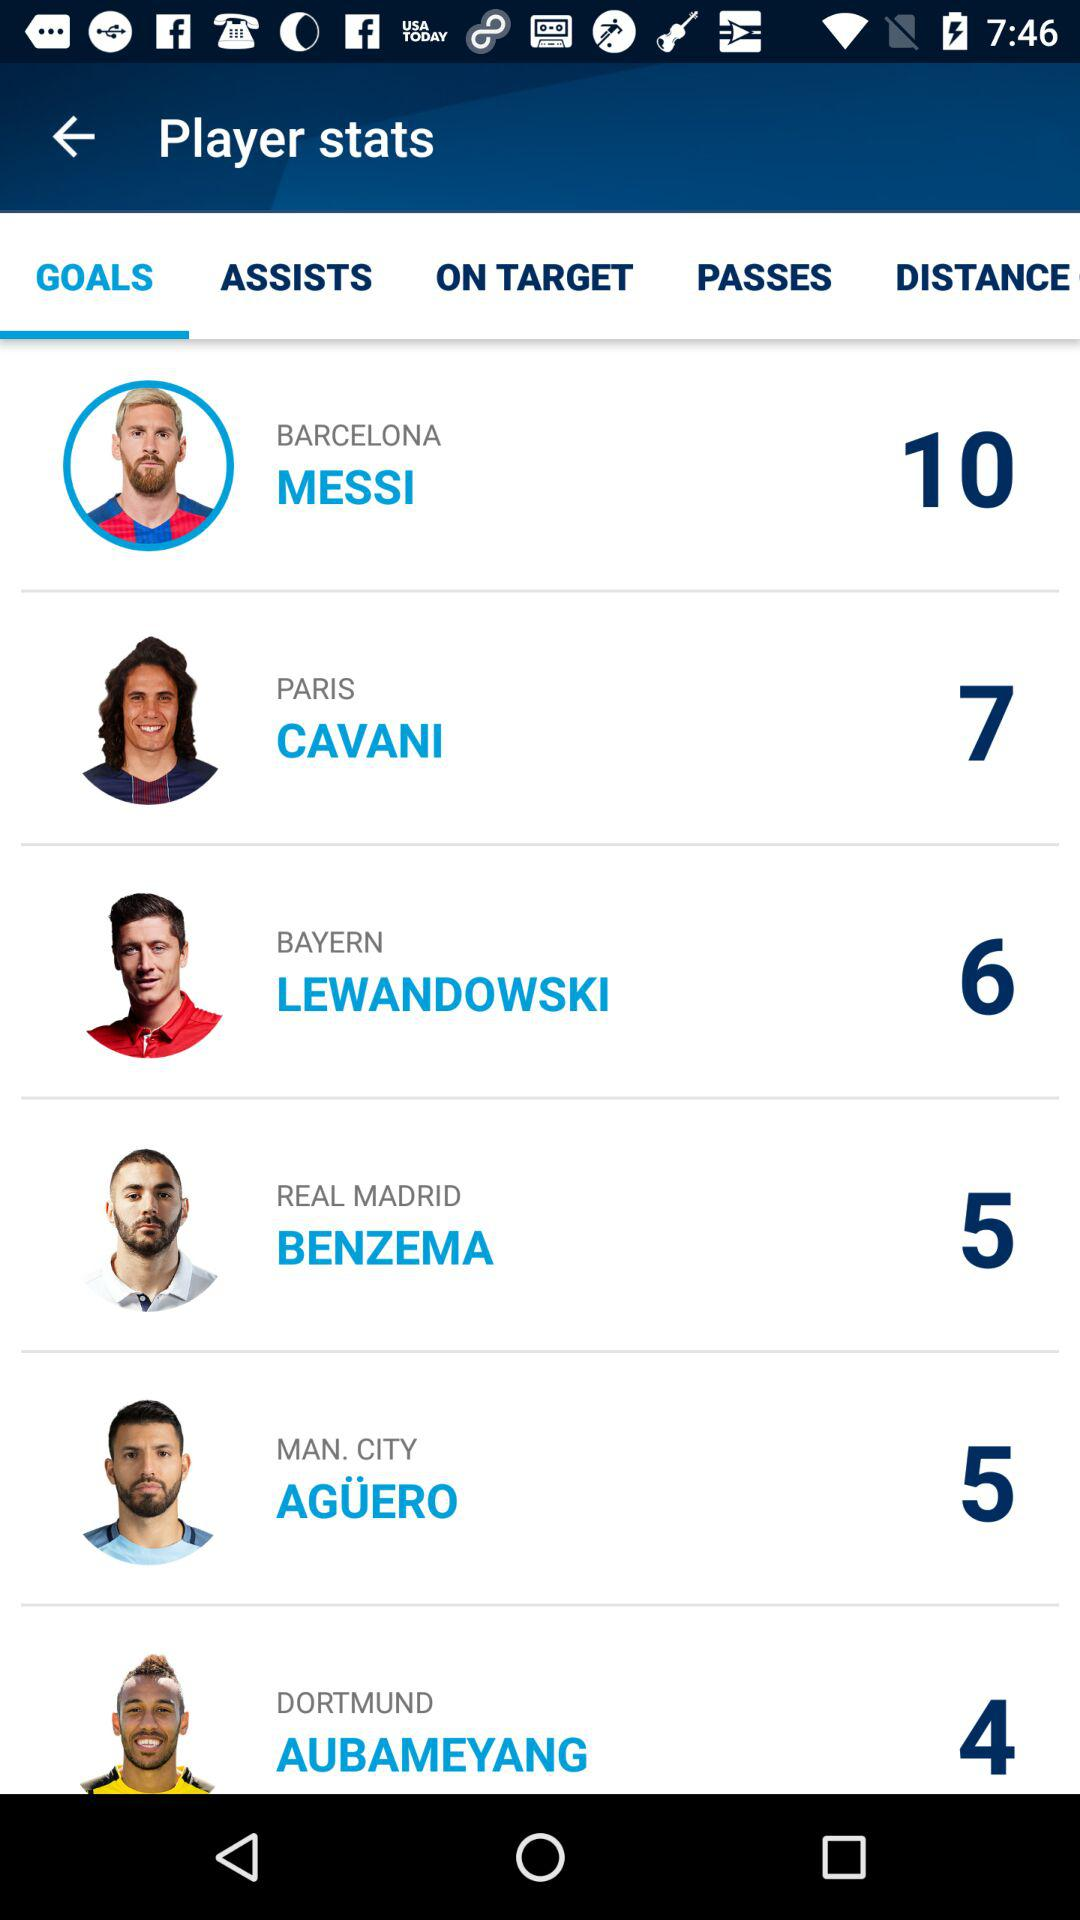Which tab is selected? The selected tab is "GOALS". 